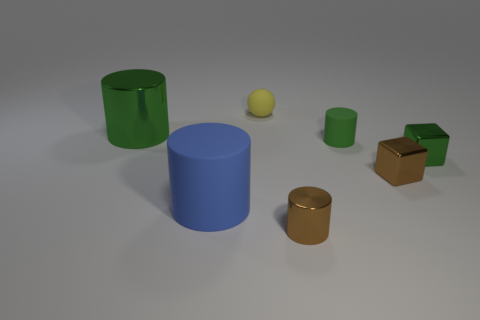Add 1 small green rubber objects. How many objects exist? 8 Subtract all cyan balls. Subtract all blue cylinders. How many balls are left? 1 Subtract all blocks. How many objects are left? 5 Add 2 small rubber objects. How many small rubber objects exist? 4 Subtract 0 gray spheres. How many objects are left? 7 Subtract all green cubes. Subtract all tiny green things. How many objects are left? 4 Add 5 large green objects. How many large green objects are left? 6 